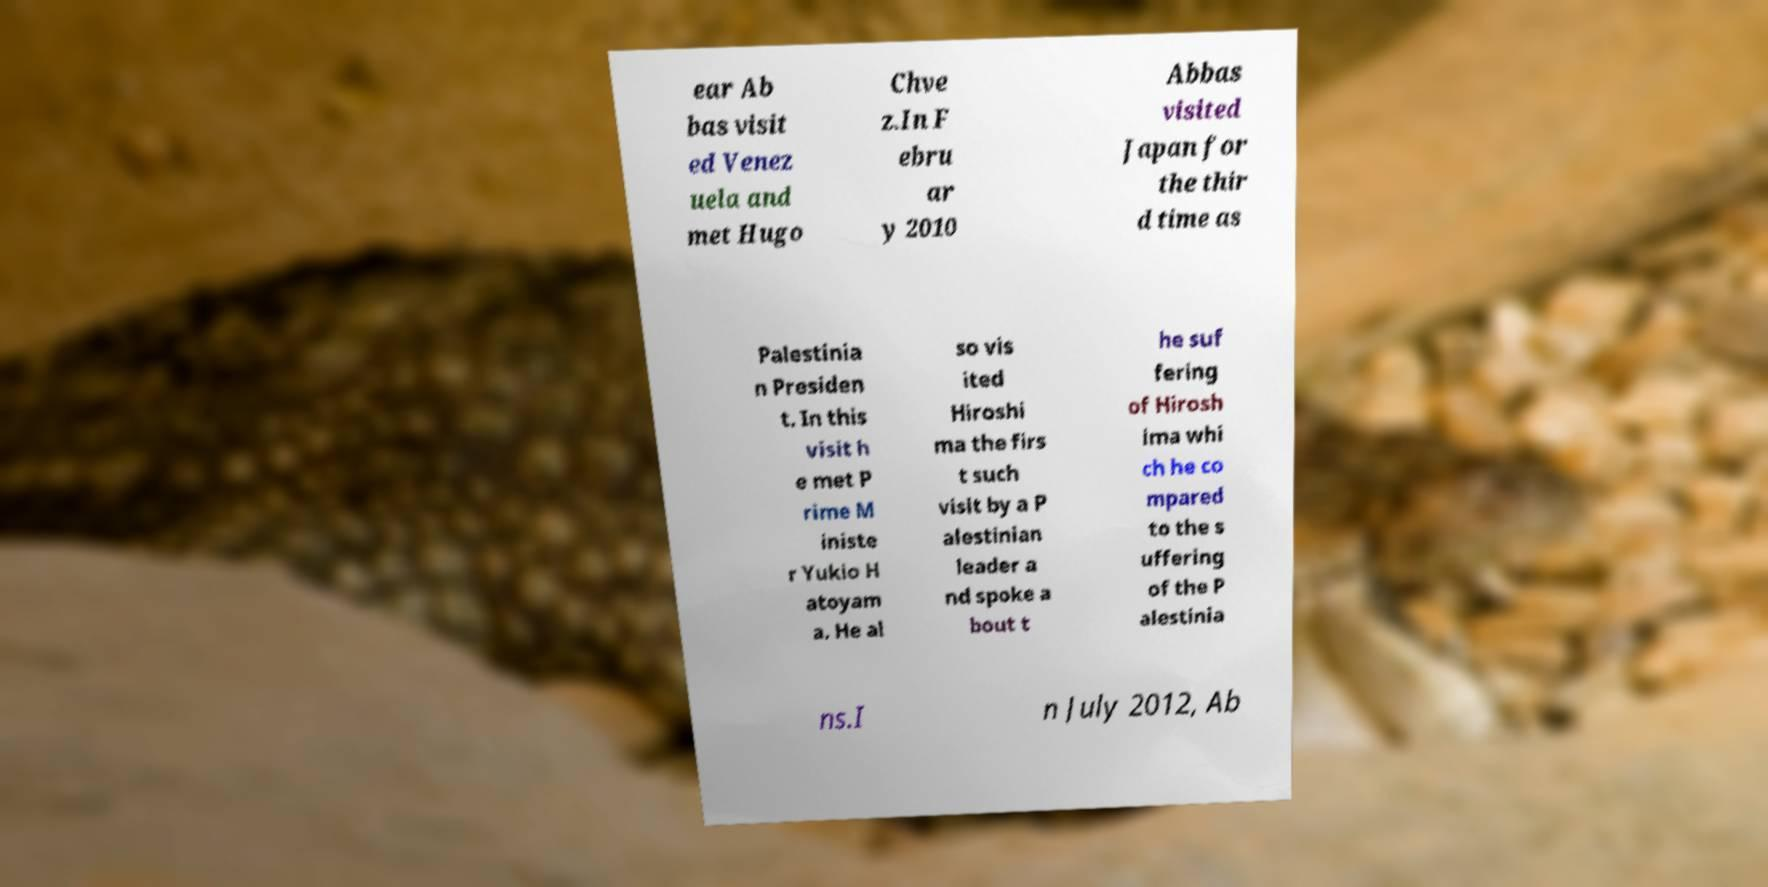Could you extract and type out the text from this image? ear Ab bas visit ed Venez uela and met Hugo Chve z.In F ebru ar y 2010 Abbas visited Japan for the thir d time as Palestinia n Presiden t. In this visit h e met P rime M iniste r Yukio H atoyam a. He al so vis ited Hiroshi ma the firs t such visit by a P alestinian leader a nd spoke a bout t he suf fering of Hirosh ima whi ch he co mpared to the s uffering of the P alestinia ns.I n July 2012, Ab 